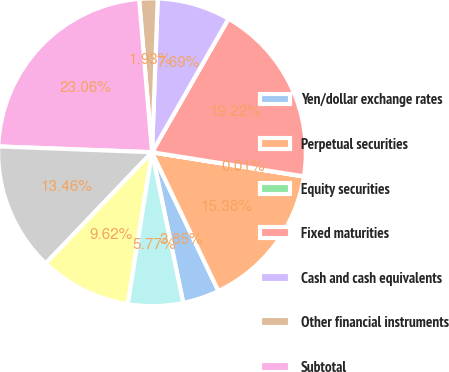<chart> <loc_0><loc_0><loc_500><loc_500><pie_chart><fcel>Yen/dollar exchange rates<fcel>Perpetual securities<fcel>Equity securities<fcel>Fixed maturities<fcel>Cash and cash equivalents<fcel>Other financial instruments<fcel>Subtotal<fcel>Notes payable<fcel>Cross-currency swaps<fcel>Japanese policyholder<nl><fcel>3.85%<fcel>15.38%<fcel>0.01%<fcel>19.22%<fcel>7.69%<fcel>1.93%<fcel>23.06%<fcel>13.46%<fcel>9.62%<fcel>5.77%<nl></chart> 